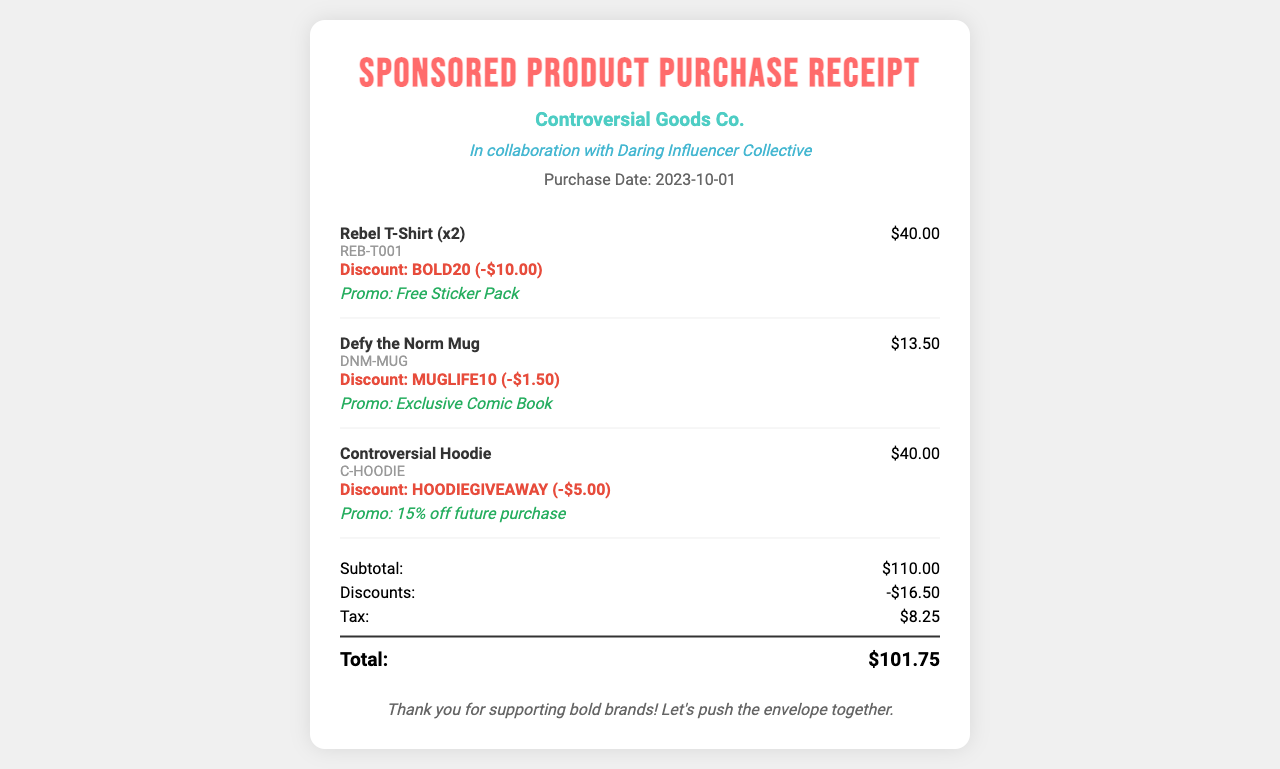What is the purchase date? The purchase date is specified in the document under the purchase details section.
Answer: 2023-10-01 How much was saved with the BOLD20 discount? The BOLD20 discount is listed in the item details, indicating the savings for that item.
Answer: -$10.00 What is the total amount spent after discounts? The total is calculated after applying discounts and adding tax, which is provided in the summary section.
Answer: $101.75 What promotional item was included with the Rebel T-Shirt? The receipt mentions promotional items corresponding to each product under the item details.
Answer: Free Sticker Pack What is the subtotal before taxes and discounts? The subtotal is listed in the summary and reflects the total before any discounts are applied.
Answer: $110.00 How much is the discount for the Controversial Hoodie? The document specifies the discount amount associated with the hoodie in the item details.
Answer: -$5.00 What is the total number of items purchased? The total number of items can be calculated by summarizing the quantities from the item list.
Answer: 5 Which brand collaborated for this purchase? The collaborating brand is mentioned in the header section of the receipt.
Answer: Daring Influencer Collective What is the tax amount calculated on the purchase? The tax amount is provided in the summary section of the receipt.
Answer: $8.25 